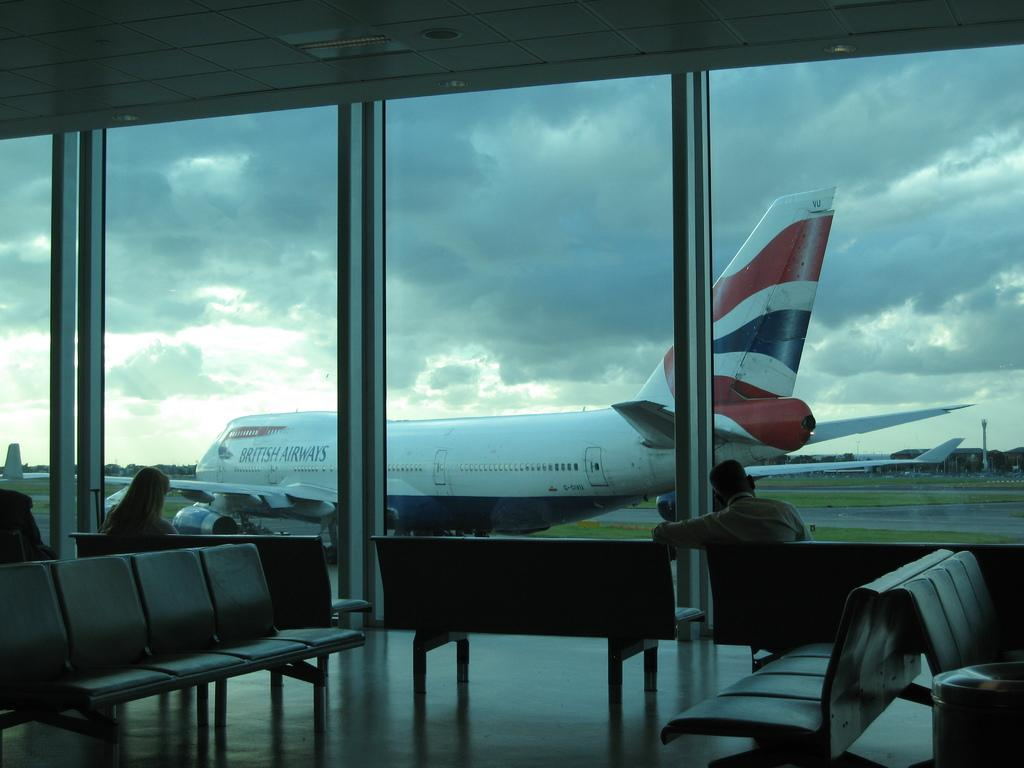What type of furniture is present in the image? There are chairs in the image. Who is sitting on the chairs? Two people are sitting on the chairs. What type of natural environment is visible in the image? There is grass visible in the image. What else can be seen in the sky besides the grass? There is a plane and clouds present in the image. How would you describe the lighting in the image? The image is slightly dark. What role does the fireman play in the aftermath of the event depicted in the image? There is no fireman or event depicted in the image; it features chairs, people, grass, a plane, clouds, and a slightly dark lighting. 